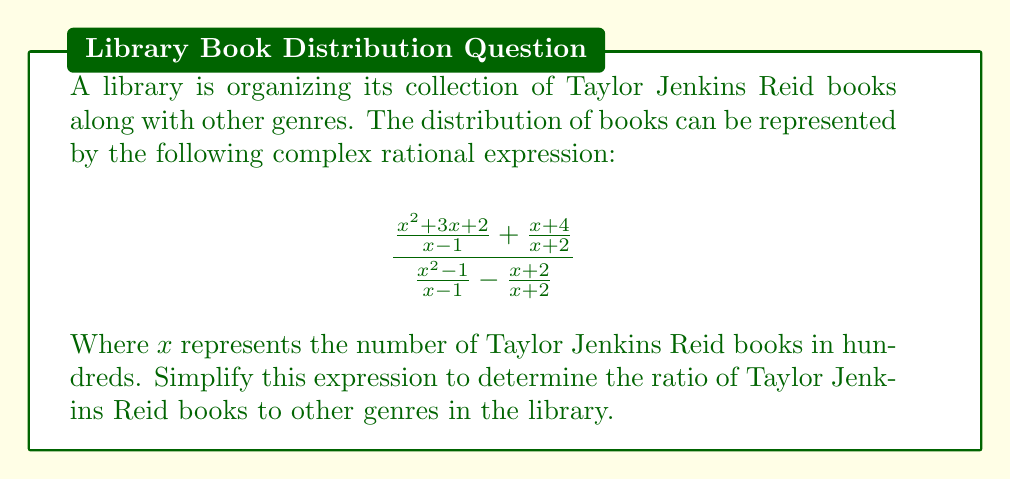Can you answer this question? Let's simplify this complex rational expression step by step:

1) First, let's simplify the numerator and denominator separately.

   Numerator: $\frac{x^2 + 3x + 2}{x - 1} + \frac{x + 4}{x + 2}$
   Denominator: $\frac{x^2 - 1}{x - 1} - \frac{x + 2}{x + 2}$

2) For the numerator:
   $\frac{x^2 + 3x + 2}{x - 1} + \frac{x + 4}{x + 2}$
   $= \frac{(x+2)(x+1)}{x-1} + \frac{x+4}{x+2}$
   $= \frac{(x+2)(x+1) + (x-1)(x+4)}{(x-1)(x+2)}$
   $= \frac{x^2 + 3x + 2 + x^2 + 3x - 4}{x^2 + x - 2}$
   $= \frac{2x^2 + 6x - 2}{x^2 + x - 2}$

3) For the denominator:
   $\frac{x^2 - 1}{x - 1} - \frac{x + 2}{x + 2}$
   $= \frac{x+1}{1} - 1$
   $= x$

4) Now our expression looks like:
   $$\frac{\frac{2x^2 + 6x - 2}{x^2 + x - 2}}{x}$$

5) Simplify further:
   $$\frac{2x^2 + 6x - 2}{x(x^2 + x - 2)}$$

6) Factor the numerator and denominator:
   $$\frac{2(x^2 + 3x - 1)}{x(x - 1)(x + 2)}$$

7) The $(x + 2)$ term cancels out in the numerator and denominator:
   $$\frac{2(x + 1)}{x(x - 1)}$$

This simplified expression represents the ratio of Taylor Jenkins Reid books to other genres in the library.
Answer: $\frac{2(x + 1)}{x(x - 1)}$ 